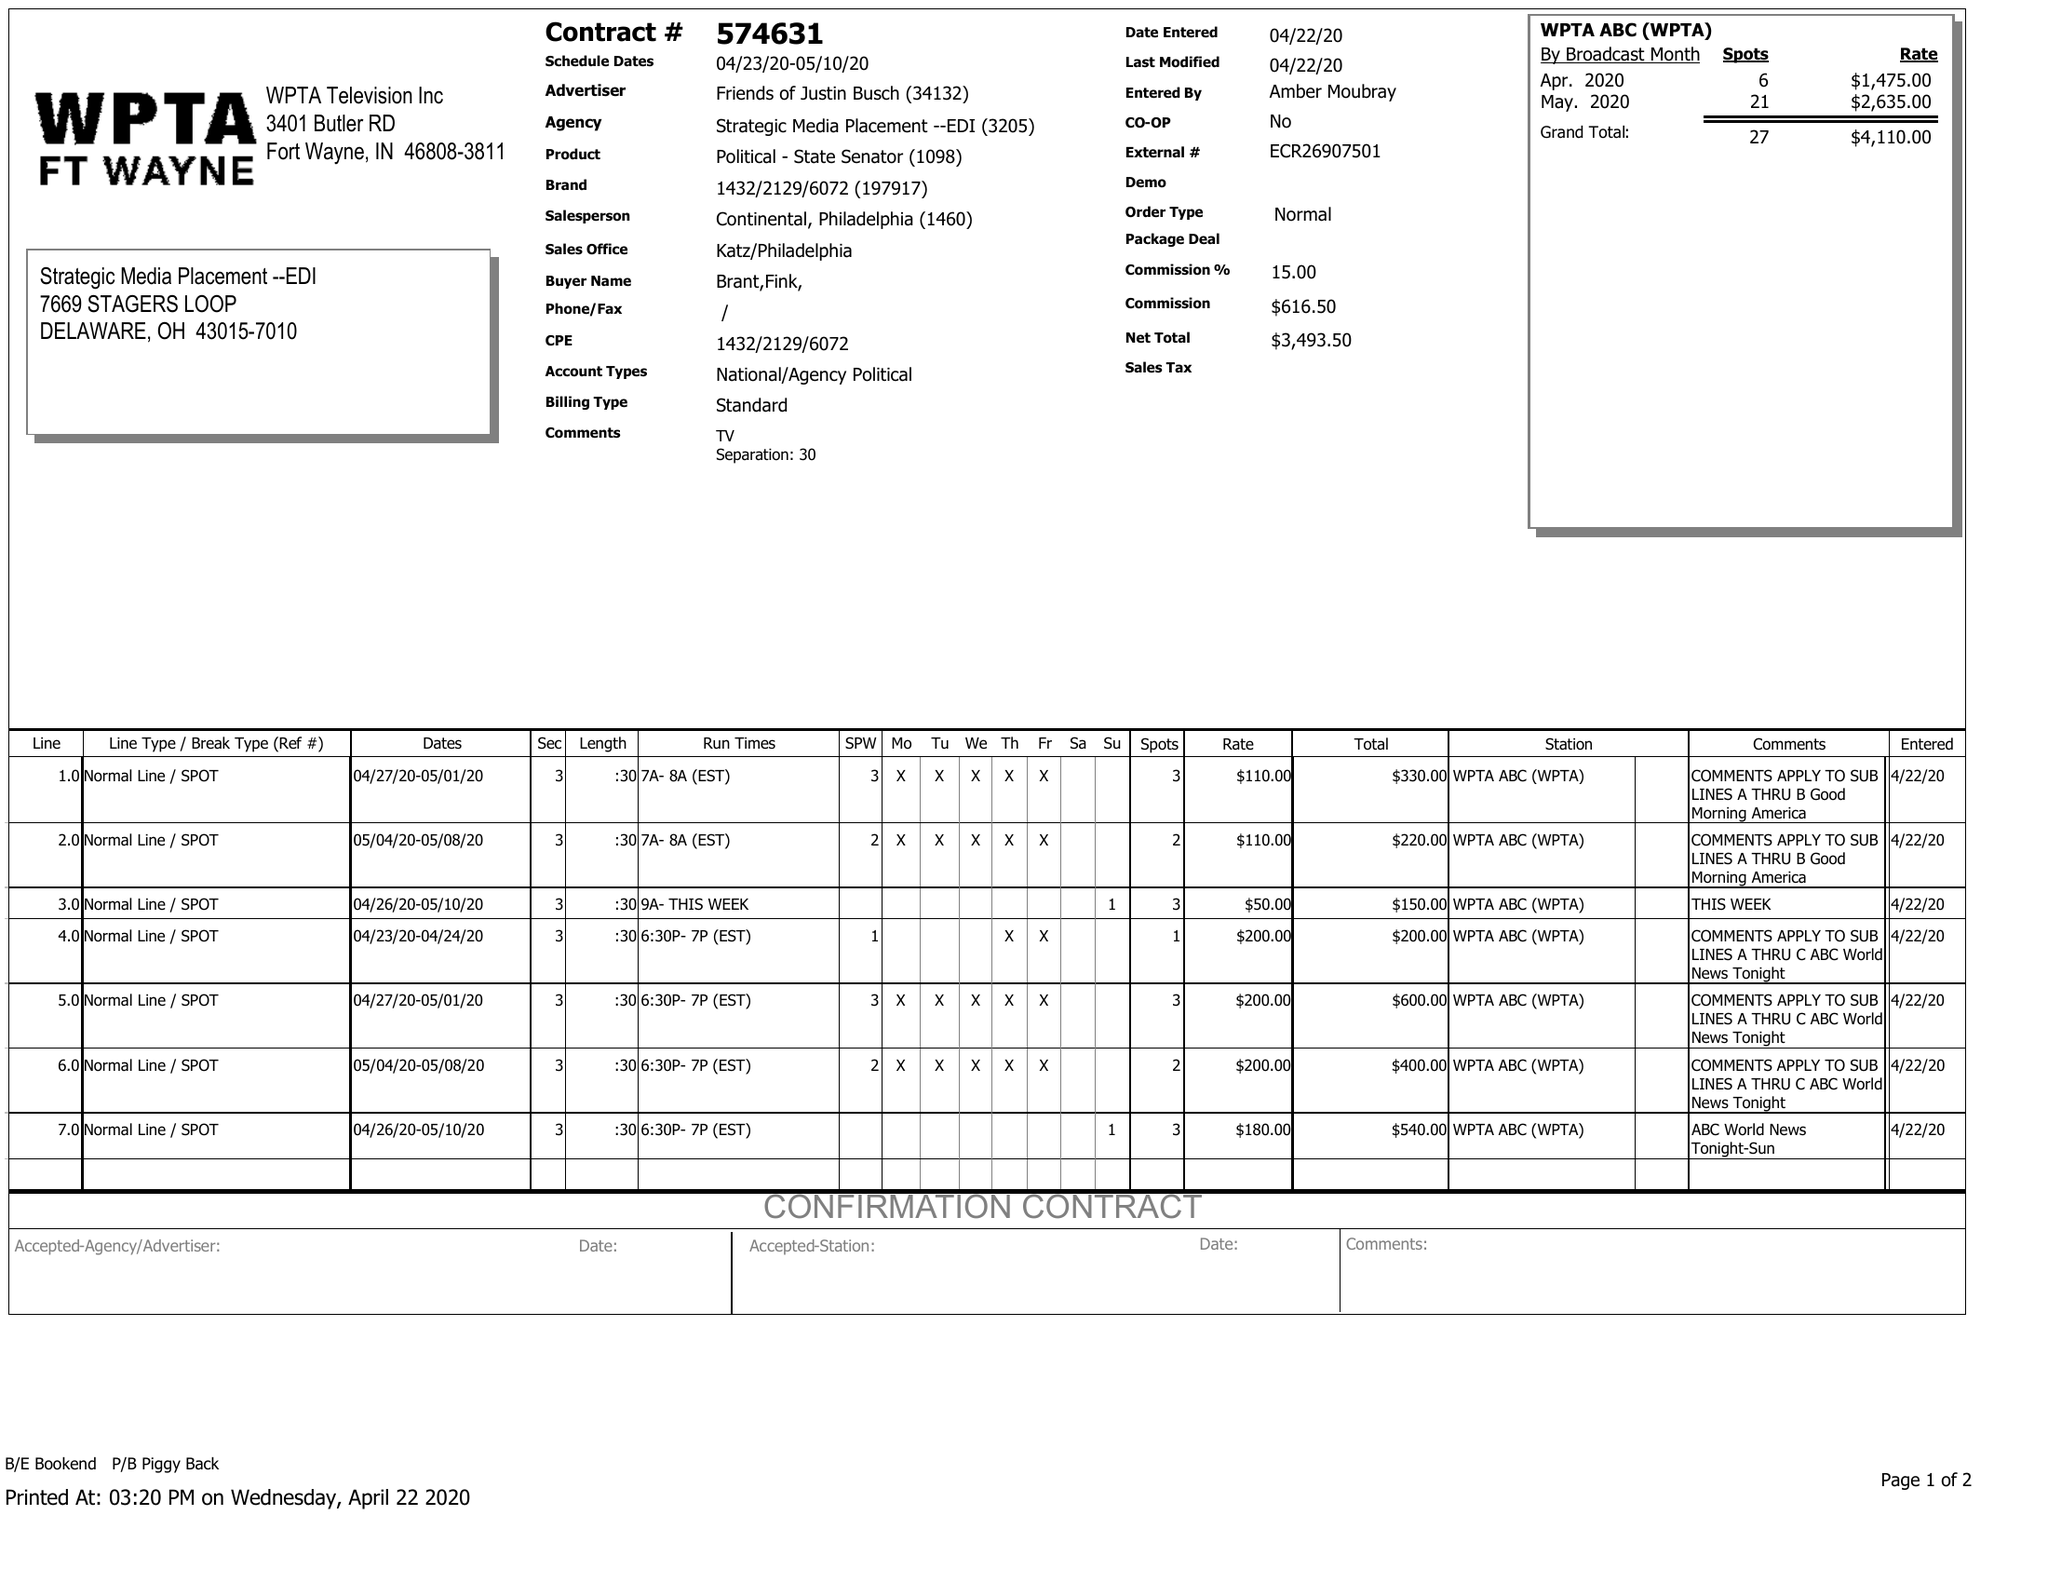What is the value for the contract_num?
Answer the question using a single word or phrase. 574631 